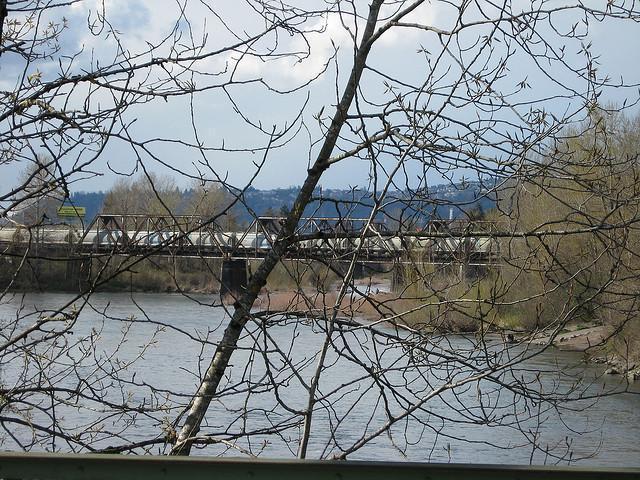How many trains are there?
Give a very brief answer. 1. How many people don't have glasses on?
Give a very brief answer. 0. 